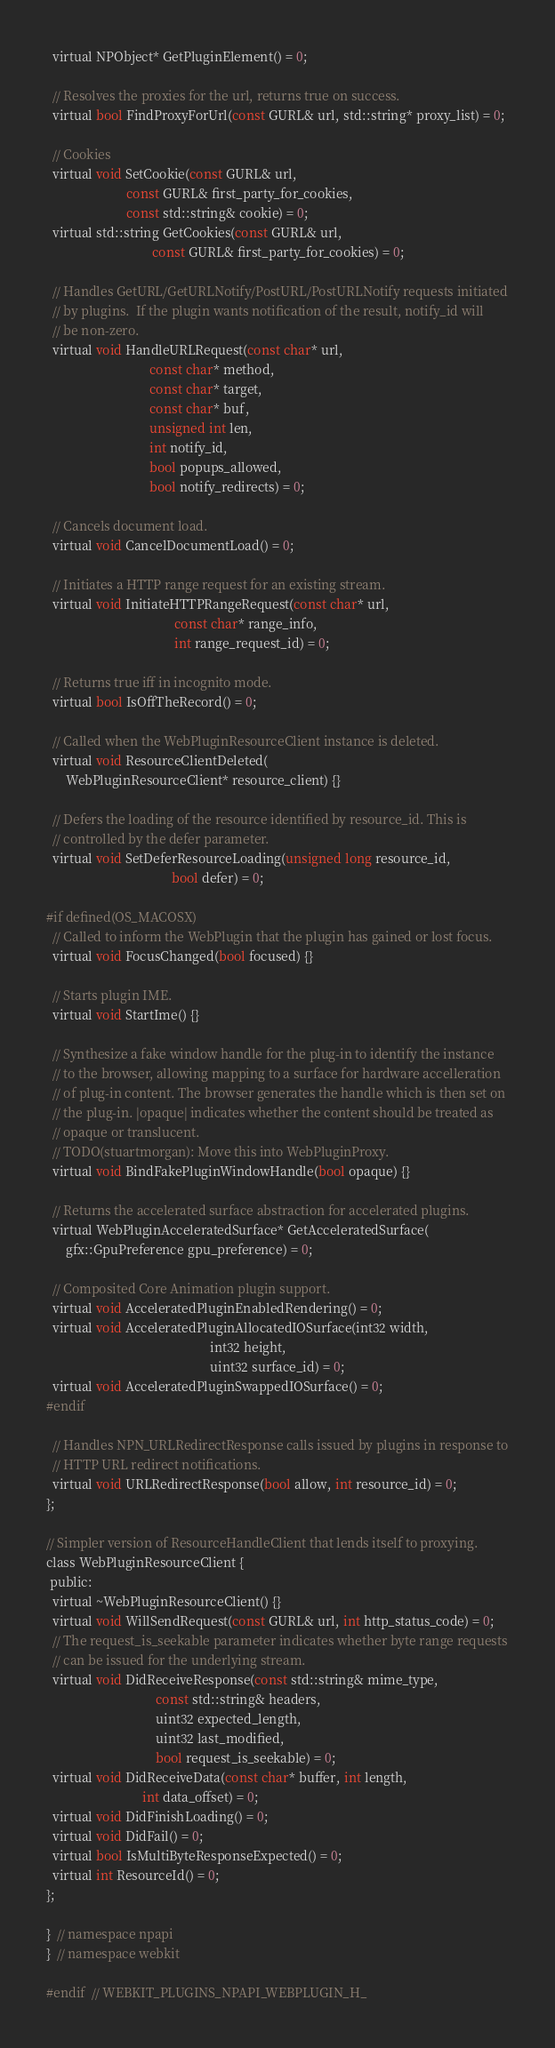<code> <loc_0><loc_0><loc_500><loc_500><_C_>  virtual NPObject* GetPluginElement() = 0;

  // Resolves the proxies for the url, returns true on success.
  virtual bool FindProxyForUrl(const GURL& url, std::string* proxy_list) = 0;

  // Cookies
  virtual void SetCookie(const GURL& url,
                         const GURL& first_party_for_cookies,
                         const std::string& cookie) = 0;
  virtual std::string GetCookies(const GURL& url,
                                 const GURL& first_party_for_cookies) = 0;

  // Handles GetURL/GetURLNotify/PostURL/PostURLNotify requests initiated
  // by plugins.  If the plugin wants notification of the result, notify_id will
  // be non-zero.
  virtual void HandleURLRequest(const char* url,
                                const char* method,
                                const char* target,
                                const char* buf,
                                unsigned int len,
                                int notify_id,
                                bool popups_allowed,
                                bool notify_redirects) = 0;

  // Cancels document load.
  virtual void CancelDocumentLoad() = 0;

  // Initiates a HTTP range request for an existing stream.
  virtual void InitiateHTTPRangeRequest(const char* url,
                                        const char* range_info,
                                        int range_request_id) = 0;

  // Returns true iff in incognito mode.
  virtual bool IsOffTheRecord() = 0;

  // Called when the WebPluginResourceClient instance is deleted.
  virtual void ResourceClientDeleted(
      WebPluginResourceClient* resource_client) {}

  // Defers the loading of the resource identified by resource_id. This is
  // controlled by the defer parameter.
  virtual void SetDeferResourceLoading(unsigned long resource_id,
                                       bool defer) = 0;

#if defined(OS_MACOSX)
  // Called to inform the WebPlugin that the plugin has gained or lost focus.
  virtual void FocusChanged(bool focused) {}

  // Starts plugin IME.
  virtual void StartIme() {}

  // Synthesize a fake window handle for the plug-in to identify the instance
  // to the browser, allowing mapping to a surface for hardware accelleration
  // of plug-in content. The browser generates the handle which is then set on
  // the plug-in. |opaque| indicates whether the content should be treated as
  // opaque or translucent.
  // TODO(stuartmorgan): Move this into WebPluginProxy.
  virtual void BindFakePluginWindowHandle(bool opaque) {}

  // Returns the accelerated surface abstraction for accelerated plugins.
  virtual WebPluginAcceleratedSurface* GetAcceleratedSurface(
      gfx::GpuPreference gpu_preference) = 0;

  // Composited Core Animation plugin support.
  virtual void AcceleratedPluginEnabledRendering() = 0;
  virtual void AcceleratedPluginAllocatedIOSurface(int32 width,
                                                   int32 height,
                                                   uint32 surface_id) = 0;
  virtual void AcceleratedPluginSwappedIOSurface() = 0;
#endif

  // Handles NPN_URLRedirectResponse calls issued by plugins in response to
  // HTTP URL redirect notifications.
  virtual void URLRedirectResponse(bool allow, int resource_id) = 0;
};

// Simpler version of ResourceHandleClient that lends itself to proxying.
class WebPluginResourceClient {
 public:
  virtual ~WebPluginResourceClient() {}
  virtual void WillSendRequest(const GURL& url, int http_status_code) = 0;
  // The request_is_seekable parameter indicates whether byte range requests
  // can be issued for the underlying stream.
  virtual void DidReceiveResponse(const std::string& mime_type,
                                  const std::string& headers,
                                  uint32 expected_length,
                                  uint32 last_modified,
                                  bool request_is_seekable) = 0;
  virtual void DidReceiveData(const char* buffer, int length,
                              int data_offset) = 0;
  virtual void DidFinishLoading() = 0;
  virtual void DidFail() = 0;
  virtual bool IsMultiByteResponseExpected() = 0;
  virtual int ResourceId() = 0;
};

}  // namespace npapi
}  // namespace webkit

#endif  // WEBKIT_PLUGINS_NPAPI_WEBPLUGIN_H_
</code> 